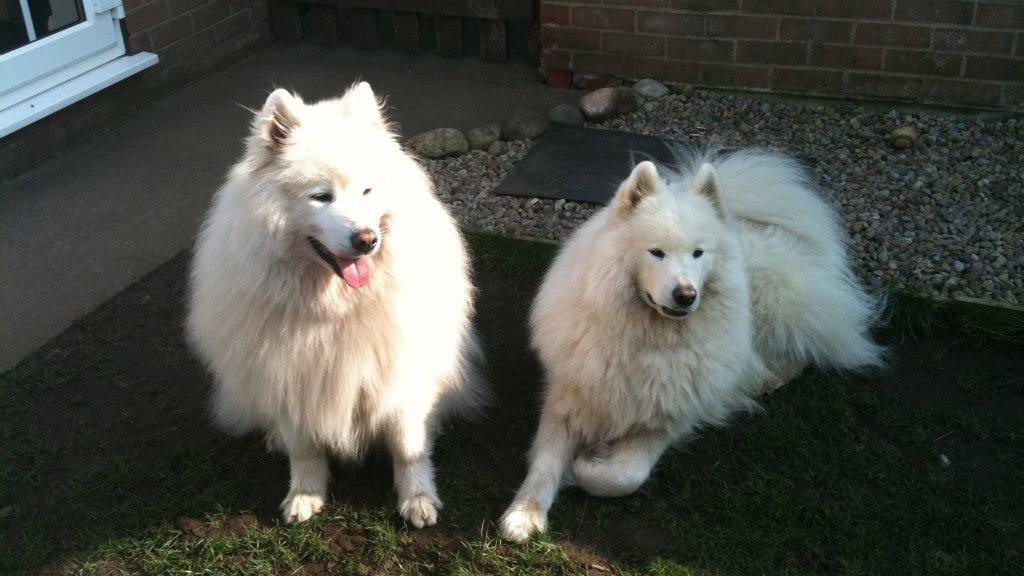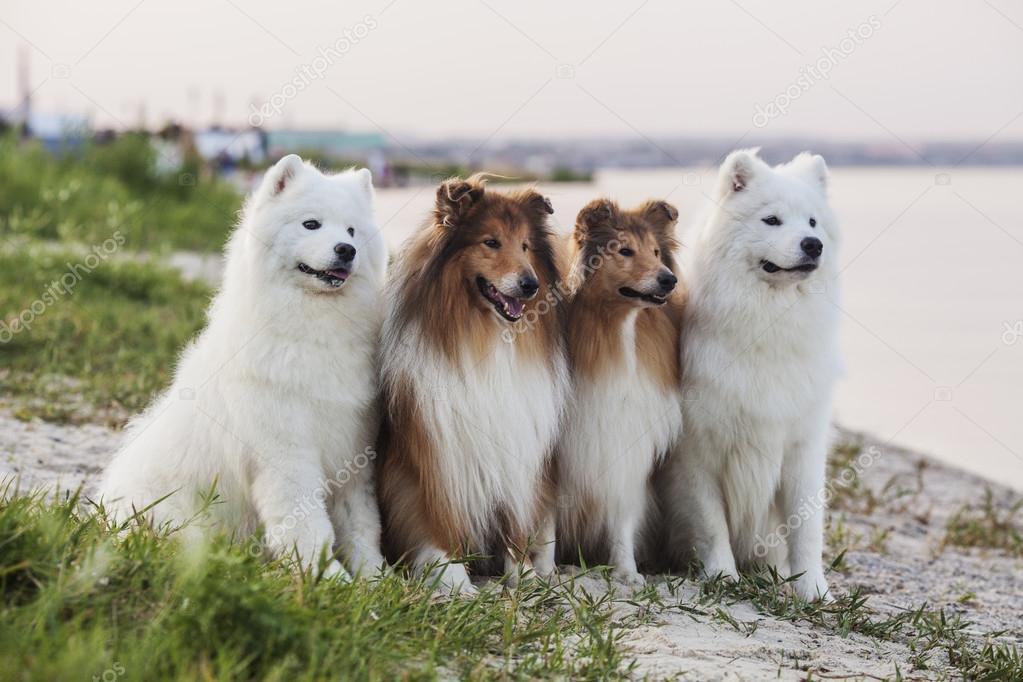The first image is the image on the left, the second image is the image on the right. Given the left and right images, does the statement "In one of the images, there are two white dogs and at least one dog of another color." hold true? Answer yes or no. Yes. The first image is the image on the left, the second image is the image on the right. Assess this claim about the two images: "In at least one image there are no less than four dogs with a white chest fur standing in a line next to each other on grass.". Correct or not? Answer yes or no. Yes. 